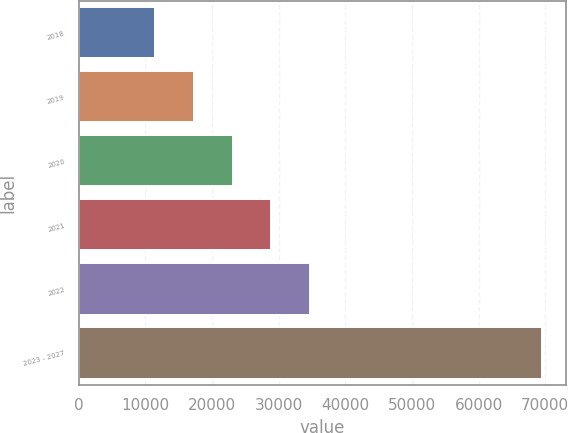<chart> <loc_0><loc_0><loc_500><loc_500><bar_chart><fcel>2018<fcel>2019<fcel>2020<fcel>2021<fcel>2022<fcel>2023 - 2027<nl><fcel>11484<fcel>17295.1<fcel>23106.2<fcel>28917.3<fcel>34728.4<fcel>69595<nl></chart> 